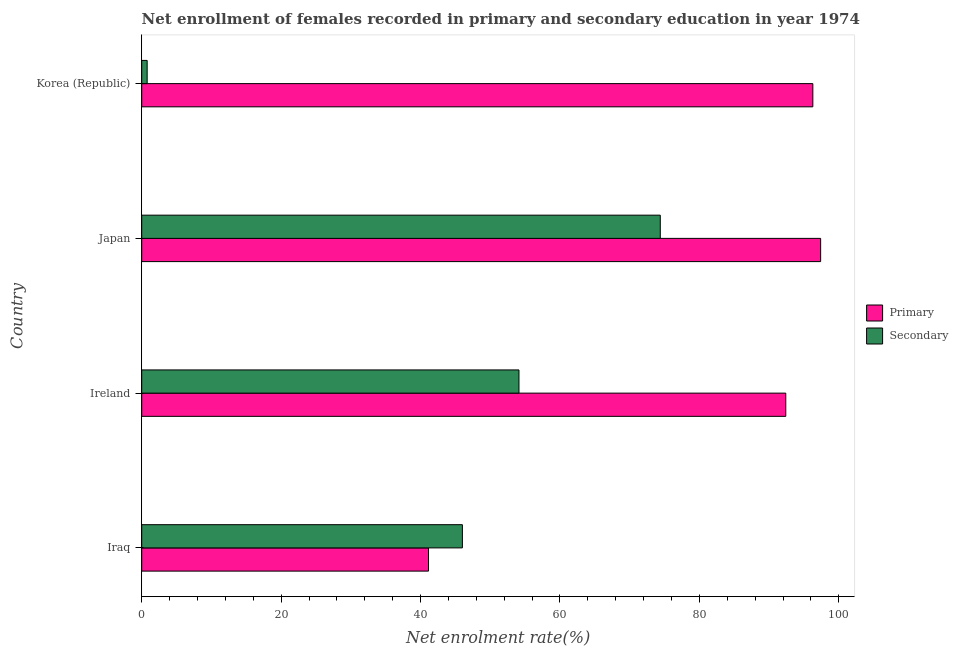Are the number of bars per tick equal to the number of legend labels?
Your answer should be compact. Yes. How many bars are there on the 1st tick from the top?
Offer a terse response. 2. What is the label of the 3rd group of bars from the top?
Give a very brief answer. Ireland. What is the enrollment rate in secondary education in Ireland?
Your answer should be compact. 54.12. Across all countries, what is the maximum enrollment rate in primary education?
Offer a very short reply. 97.39. Across all countries, what is the minimum enrollment rate in secondary education?
Ensure brevity in your answer.  0.78. In which country was the enrollment rate in secondary education minimum?
Provide a succinct answer. Korea (Republic). What is the total enrollment rate in secondary education in the graph?
Your answer should be very brief. 175.28. What is the difference between the enrollment rate in secondary education in Iraq and that in Japan?
Your response must be concise. -28.39. What is the difference between the enrollment rate in primary education in Ireland and the enrollment rate in secondary education in Iraq?
Provide a short and direct response. 46.39. What is the average enrollment rate in secondary education per country?
Your answer should be compact. 43.82. What is the difference between the enrollment rate in primary education and enrollment rate in secondary education in Korea (Republic)?
Make the answer very short. 95.49. What is the ratio of the enrollment rate in primary education in Ireland to that in Korea (Republic)?
Your response must be concise. 0.96. Is the difference between the enrollment rate in primary education in Ireland and Korea (Republic) greater than the difference between the enrollment rate in secondary education in Ireland and Korea (Republic)?
Provide a succinct answer. No. What is the difference between the highest and the second highest enrollment rate in secondary education?
Your answer should be very brief. 20.27. What is the difference between the highest and the lowest enrollment rate in secondary education?
Ensure brevity in your answer.  73.61. What does the 2nd bar from the top in Japan represents?
Offer a terse response. Primary. What does the 1st bar from the bottom in Iraq represents?
Offer a terse response. Primary. Are the values on the major ticks of X-axis written in scientific E-notation?
Your answer should be very brief. No. Does the graph contain grids?
Provide a short and direct response. No. How many legend labels are there?
Provide a succinct answer. 2. How are the legend labels stacked?
Your response must be concise. Vertical. What is the title of the graph?
Keep it short and to the point. Net enrollment of females recorded in primary and secondary education in year 1974. Does "Non-solid fuel" appear as one of the legend labels in the graph?
Give a very brief answer. No. What is the label or title of the X-axis?
Keep it short and to the point. Net enrolment rate(%). What is the Net enrolment rate(%) in Primary in Iraq?
Your answer should be compact. 41.14. What is the Net enrolment rate(%) in Secondary in Iraq?
Your answer should be compact. 46. What is the Net enrolment rate(%) of Primary in Ireland?
Ensure brevity in your answer.  92.39. What is the Net enrolment rate(%) in Secondary in Ireland?
Your answer should be very brief. 54.12. What is the Net enrolment rate(%) of Primary in Japan?
Keep it short and to the point. 97.39. What is the Net enrolment rate(%) in Secondary in Japan?
Give a very brief answer. 74.39. What is the Net enrolment rate(%) in Primary in Korea (Republic)?
Ensure brevity in your answer.  96.27. What is the Net enrolment rate(%) of Secondary in Korea (Republic)?
Make the answer very short. 0.78. Across all countries, what is the maximum Net enrolment rate(%) in Primary?
Your answer should be very brief. 97.39. Across all countries, what is the maximum Net enrolment rate(%) in Secondary?
Ensure brevity in your answer.  74.39. Across all countries, what is the minimum Net enrolment rate(%) in Primary?
Provide a short and direct response. 41.14. Across all countries, what is the minimum Net enrolment rate(%) of Secondary?
Keep it short and to the point. 0.78. What is the total Net enrolment rate(%) of Primary in the graph?
Your response must be concise. 327.19. What is the total Net enrolment rate(%) of Secondary in the graph?
Your answer should be very brief. 175.28. What is the difference between the Net enrolment rate(%) in Primary in Iraq and that in Ireland?
Keep it short and to the point. -51.25. What is the difference between the Net enrolment rate(%) in Secondary in Iraq and that in Ireland?
Offer a terse response. -8.12. What is the difference between the Net enrolment rate(%) of Primary in Iraq and that in Japan?
Make the answer very short. -56.25. What is the difference between the Net enrolment rate(%) in Secondary in Iraq and that in Japan?
Give a very brief answer. -28.39. What is the difference between the Net enrolment rate(%) of Primary in Iraq and that in Korea (Republic)?
Give a very brief answer. -55.13. What is the difference between the Net enrolment rate(%) of Secondary in Iraq and that in Korea (Republic)?
Provide a succinct answer. 45.22. What is the difference between the Net enrolment rate(%) in Primary in Ireland and that in Japan?
Give a very brief answer. -5. What is the difference between the Net enrolment rate(%) of Secondary in Ireland and that in Japan?
Offer a very short reply. -20.27. What is the difference between the Net enrolment rate(%) in Primary in Ireland and that in Korea (Republic)?
Offer a very short reply. -3.88. What is the difference between the Net enrolment rate(%) in Secondary in Ireland and that in Korea (Republic)?
Your answer should be compact. 53.34. What is the difference between the Net enrolment rate(%) of Primary in Japan and that in Korea (Republic)?
Offer a terse response. 1.12. What is the difference between the Net enrolment rate(%) of Secondary in Japan and that in Korea (Republic)?
Your answer should be compact. 73.61. What is the difference between the Net enrolment rate(%) of Primary in Iraq and the Net enrolment rate(%) of Secondary in Ireland?
Offer a terse response. -12.98. What is the difference between the Net enrolment rate(%) in Primary in Iraq and the Net enrolment rate(%) in Secondary in Japan?
Keep it short and to the point. -33.25. What is the difference between the Net enrolment rate(%) of Primary in Iraq and the Net enrolment rate(%) of Secondary in Korea (Republic)?
Offer a terse response. 40.36. What is the difference between the Net enrolment rate(%) of Primary in Ireland and the Net enrolment rate(%) of Secondary in Japan?
Your answer should be compact. 18. What is the difference between the Net enrolment rate(%) of Primary in Ireland and the Net enrolment rate(%) of Secondary in Korea (Republic)?
Give a very brief answer. 91.61. What is the difference between the Net enrolment rate(%) in Primary in Japan and the Net enrolment rate(%) in Secondary in Korea (Republic)?
Your answer should be very brief. 96.61. What is the average Net enrolment rate(%) of Primary per country?
Ensure brevity in your answer.  81.8. What is the average Net enrolment rate(%) in Secondary per country?
Provide a succinct answer. 43.82. What is the difference between the Net enrolment rate(%) of Primary and Net enrolment rate(%) of Secondary in Iraq?
Give a very brief answer. -4.86. What is the difference between the Net enrolment rate(%) in Primary and Net enrolment rate(%) in Secondary in Ireland?
Ensure brevity in your answer.  38.27. What is the difference between the Net enrolment rate(%) in Primary and Net enrolment rate(%) in Secondary in Japan?
Provide a short and direct response. 23. What is the difference between the Net enrolment rate(%) in Primary and Net enrolment rate(%) in Secondary in Korea (Republic)?
Provide a succinct answer. 95.49. What is the ratio of the Net enrolment rate(%) of Primary in Iraq to that in Ireland?
Ensure brevity in your answer.  0.45. What is the ratio of the Net enrolment rate(%) of Primary in Iraq to that in Japan?
Provide a short and direct response. 0.42. What is the ratio of the Net enrolment rate(%) of Secondary in Iraq to that in Japan?
Your answer should be compact. 0.62. What is the ratio of the Net enrolment rate(%) in Primary in Iraq to that in Korea (Republic)?
Offer a very short reply. 0.43. What is the ratio of the Net enrolment rate(%) of Secondary in Iraq to that in Korea (Republic)?
Keep it short and to the point. 59.04. What is the ratio of the Net enrolment rate(%) of Primary in Ireland to that in Japan?
Keep it short and to the point. 0.95. What is the ratio of the Net enrolment rate(%) of Secondary in Ireland to that in Japan?
Keep it short and to the point. 0.73. What is the ratio of the Net enrolment rate(%) of Primary in Ireland to that in Korea (Republic)?
Provide a succinct answer. 0.96. What is the ratio of the Net enrolment rate(%) of Secondary in Ireland to that in Korea (Republic)?
Provide a short and direct response. 69.46. What is the ratio of the Net enrolment rate(%) of Primary in Japan to that in Korea (Republic)?
Give a very brief answer. 1.01. What is the ratio of the Net enrolment rate(%) in Secondary in Japan to that in Korea (Republic)?
Provide a short and direct response. 95.48. What is the difference between the highest and the second highest Net enrolment rate(%) of Primary?
Offer a very short reply. 1.12. What is the difference between the highest and the second highest Net enrolment rate(%) in Secondary?
Make the answer very short. 20.27. What is the difference between the highest and the lowest Net enrolment rate(%) of Primary?
Ensure brevity in your answer.  56.25. What is the difference between the highest and the lowest Net enrolment rate(%) in Secondary?
Provide a short and direct response. 73.61. 